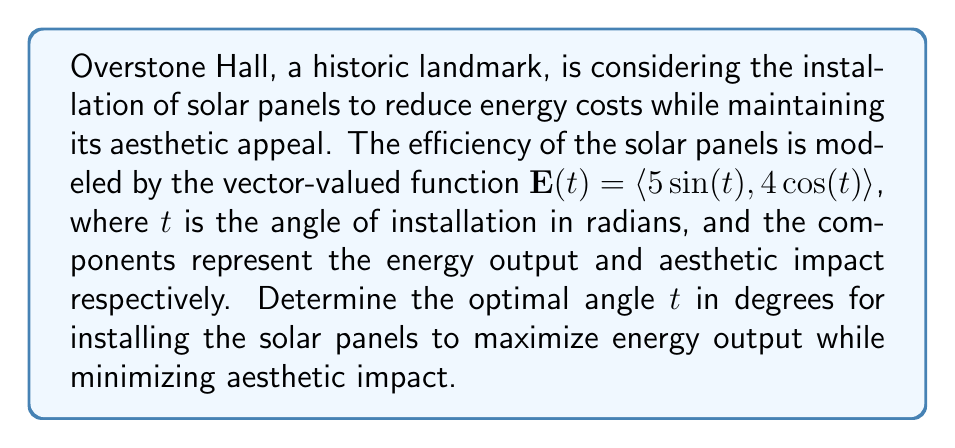What is the answer to this math problem? To solve this problem, we need to find the maximum magnitude of the vector-valued function $\mathbf{E}(t)$. This will give us the optimal balance between energy output and aesthetic impact.

1) The magnitude of $\mathbf{E}(t)$ is given by:
   $$|\mathbf{E}(t)| = \sqrt{(5\sin(t))^2 + (4\cos(t))^2}$$

2) To find the maximum, we need to differentiate $|\mathbf{E}(t)|^2$ with respect to $t$ and set it to zero:
   $$\frac{d}{dt}(|\mathbf{E}(t)|^2) = \frac{d}{dt}(25\sin^2(t) + 16\cos^2(t)) = 0$$

3) Using the chain rule and trigonometric identities:
   $$50\sin(t)\cos(t) - 32\sin(t)\cos(t) = 0$$
   $$18\sin(t)\cos(t) = 0$$

4) This equation is satisfied when either $\sin(t) = 0$ or $\cos(t) = 0$, or when $t = \frac{\pi}{4}$ or $t = \frac{3\pi}{4}$.

5) Evaluating $|\mathbf{E}(t)|$ at these points:
   At $t = \frac{\pi}{4}$: $|\mathbf{E}(\frac{\pi}{4})| = \sqrt{25(\frac{\sqrt{2}}{2})^2 + 16(\frac{\sqrt{2}}{2})^2} = \sqrt{20.5} \approx 4.53$
   At $t = \frac{3\pi}{4}$: $|\mathbf{E}(\frac{3\pi}{4})| = \sqrt{25(\frac{\sqrt{2}}{2})^2 + 16(-\frac{\sqrt{2}}{2})^2} = \sqrt{20.5} \approx 4.53$

6) Both angles yield the same maximum magnitude, but $\frac{\pi}{4}$ is in the first quadrant, which is more practical for solar panel installation.

7) Converting $\frac{\pi}{4}$ radians to degrees:
   $$\frac{\pi}{4} \cdot \frac{180^{\circ}}{\pi} = 45^{\circ}$$

Therefore, the optimal angle for installing the solar panels is 45°.
Answer: 45° 